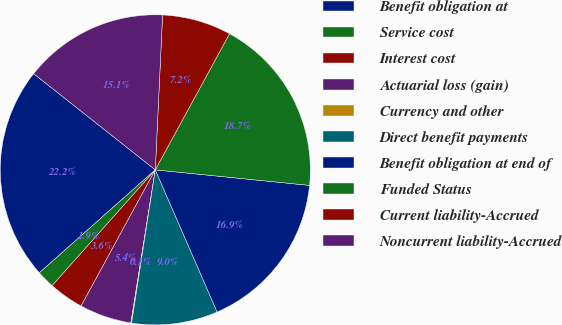Convert chart. <chart><loc_0><loc_0><loc_500><loc_500><pie_chart><fcel>Benefit obligation at<fcel>Service cost<fcel>Interest cost<fcel>Actuarial loss (gain)<fcel>Currency and other<fcel>Direct benefit payments<fcel>Benefit obligation at end of<fcel>Funded Status<fcel>Current liability-Accrued<fcel>Noncurrent liability-Accrued<nl><fcel>22.21%<fcel>1.86%<fcel>3.64%<fcel>5.42%<fcel>0.08%<fcel>8.97%<fcel>16.87%<fcel>18.65%<fcel>7.2%<fcel>15.1%<nl></chart> 